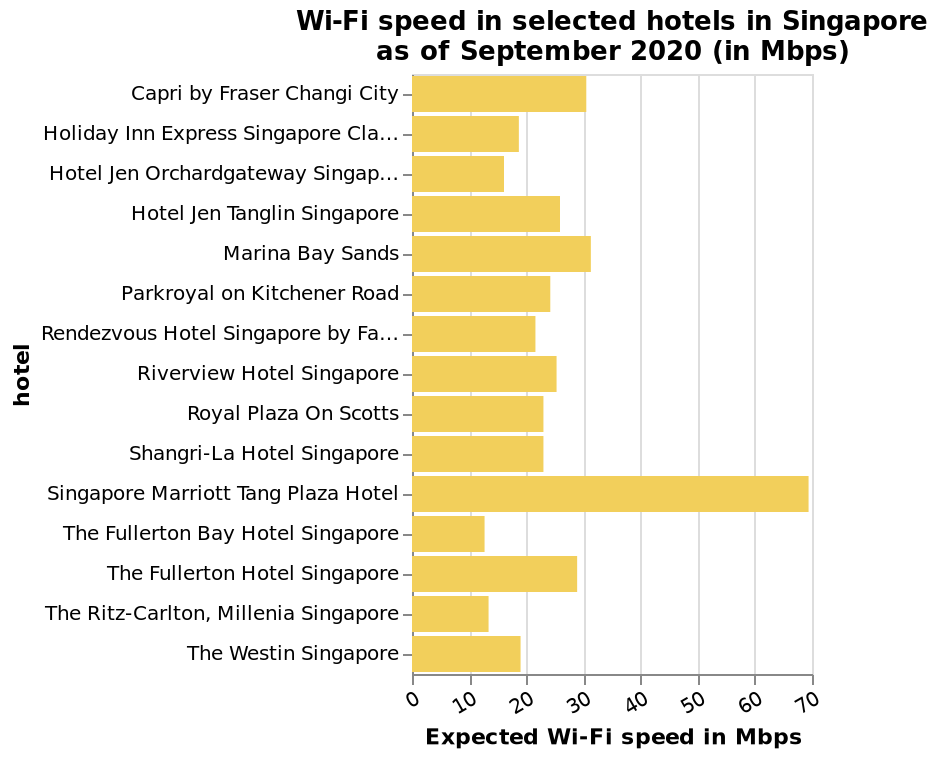<image>
What does the y-axis represent on the bar chart? The y-axis represents the hotels in Singapore, listed in order from Capri by Fraser Changi City to The Westin Singapore. Is there any particular venue in Singapore where Wi-Fi speed stands out? Yes, the Marriott has Wi-Fi speed that exceeds all other venues. What is the name of the last hotel listed on the y-axis? The last hotel listed on the y-axis is The Westin Singapore. What is the Wi-Fi speed like in Singapore?  Wi-fi speeds in Singapore are generally quite slow. How does the Wi-Fi speed at the Marriott compare to other venues in Singapore?  The speed at the Marriott exceeds all other venues in Singapore. What is the name of the first hotel listed on the y-axis? The first hotel listed on the y-axis is Capri by Fraser Changi City. 